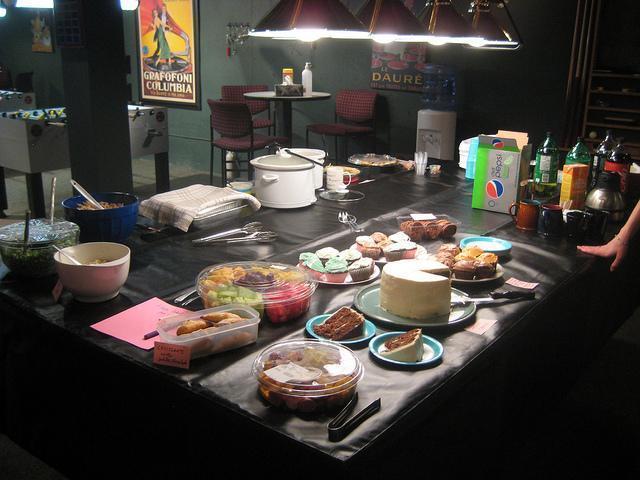How many chairs in the background?
Give a very brief answer. 3. How many cakes are on the table?
Give a very brief answer. 1. How many tiers is the cupcake holder?
Give a very brief answer. 1. How many dining tables are in the photo?
Give a very brief answer. 2. How many bowls are in the photo?
Give a very brief answer. 3. How many chairs are in the picture?
Give a very brief answer. 2. 